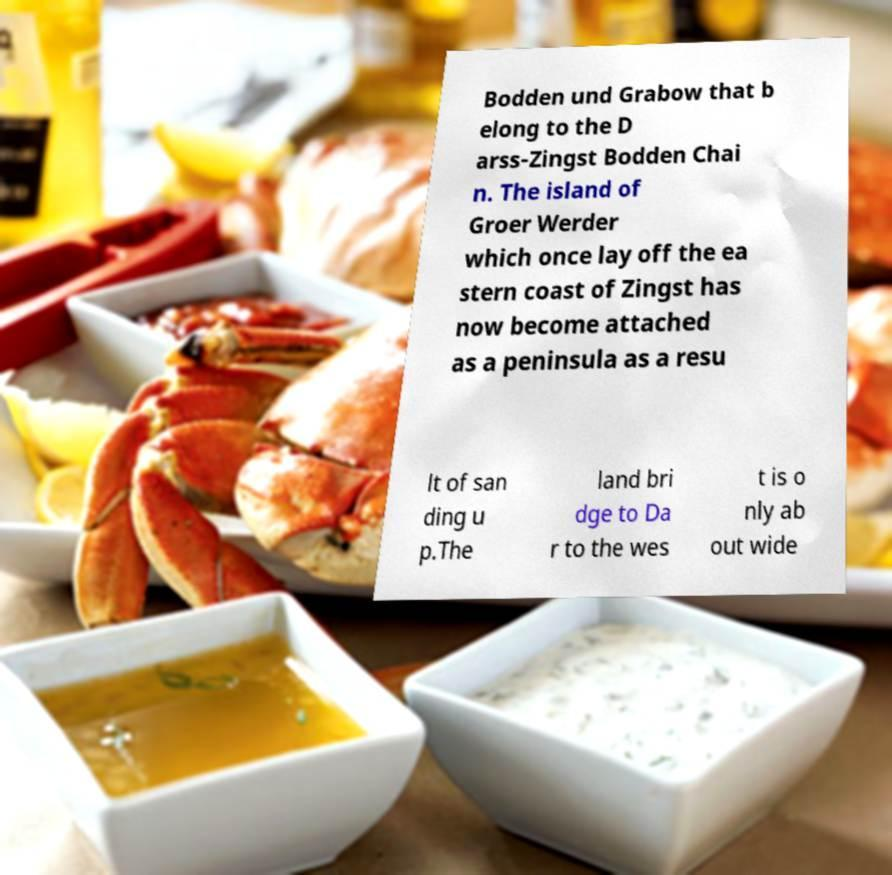Could you extract and type out the text from this image? Bodden und Grabow that b elong to the D arss-Zingst Bodden Chai n. The island of Groer Werder which once lay off the ea stern coast of Zingst has now become attached as a peninsula as a resu lt of san ding u p.The land bri dge to Da r to the wes t is o nly ab out wide 